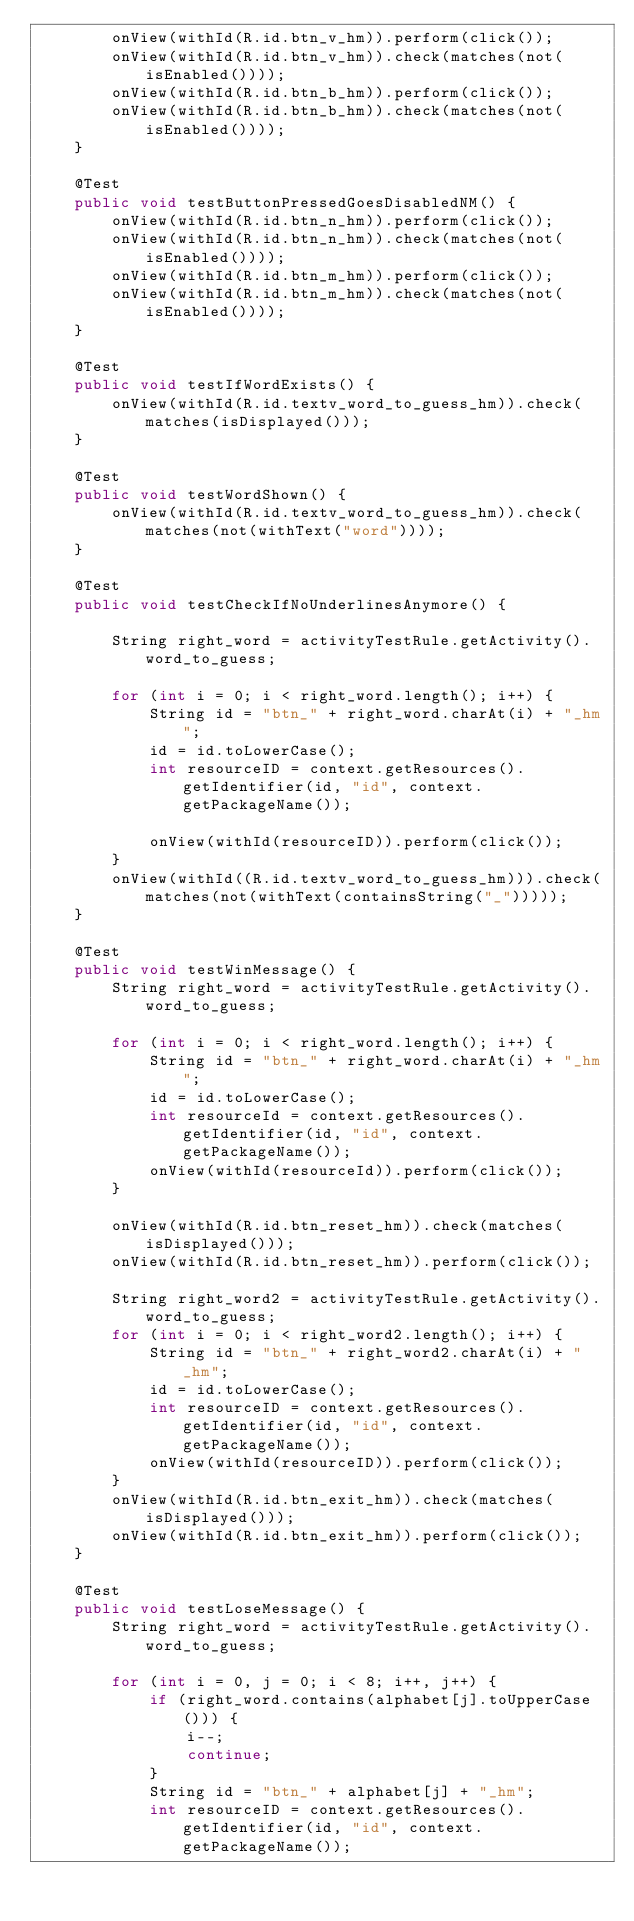<code> <loc_0><loc_0><loc_500><loc_500><_Java_>        onView(withId(R.id.btn_v_hm)).perform(click());
        onView(withId(R.id.btn_v_hm)).check(matches(not(isEnabled())));
        onView(withId(R.id.btn_b_hm)).perform(click());
        onView(withId(R.id.btn_b_hm)).check(matches(not(isEnabled())));
    }

    @Test
    public void testButtonPressedGoesDisabledNM() {
        onView(withId(R.id.btn_n_hm)).perform(click());
        onView(withId(R.id.btn_n_hm)).check(matches(not(isEnabled())));
        onView(withId(R.id.btn_m_hm)).perform(click());
        onView(withId(R.id.btn_m_hm)).check(matches(not(isEnabled())));
    }

    @Test
    public void testIfWordExists() {
        onView(withId(R.id.textv_word_to_guess_hm)).check(matches(isDisplayed()));
    }

    @Test
    public void testWordShown() {
        onView(withId(R.id.textv_word_to_guess_hm)).check(matches(not(withText("word"))));
    }

    @Test
    public void testCheckIfNoUnderlinesAnymore() {

        String right_word = activityTestRule.getActivity().word_to_guess;

        for (int i = 0; i < right_word.length(); i++) {
            String id = "btn_" + right_word.charAt(i) + "_hm";
            id = id.toLowerCase();
            int resourceID = context.getResources().getIdentifier(id, "id", context.getPackageName());

            onView(withId(resourceID)).perform(click());
        }
        onView(withId((R.id.textv_word_to_guess_hm))).check(matches(not(withText(containsString("_")))));
    }

    @Test
    public void testWinMessage() {
        String right_word = activityTestRule.getActivity().word_to_guess;

        for (int i = 0; i < right_word.length(); i++) {
            String id = "btn_" + right_word.charAt(i) + "_hm";
            id = id.toLowerCase();
            int resourceId = context.getResources().getIdentifier(id, "id", context.getPackageName());
            onView(withId(resourceId)).perform(click());
        }

        onView(withId(R.id.btn_reset_hm)).check(matches(isDisplayed()));
        onView(withId(R.id.btn_reset_hm)).perform(click());

        String right_word2 = activityTestRule.getActivity().word_to_guess;
        for (int i = 0; i < right_word2.length(); i++) {
            String id = "btn_" + right_word2.charAt(i) + "_hm";
            id = id.toLowerCase();
            int resourceID = context.getResources().getIdentifier(id, "id", context.getPackageName());
            onView(withId(resourceID)).perform(click());
        }
        onView(withId(R.id.btn_exit_hm)).check(matches(isDisplayed()));
        onView(withId(R.id.btn_exit_hm)).perform(click());
    }

    @Test
    public void testLoseMessage() {
        String right_word = activityTestRule.getActivity().word_to_guess;

        for (int i = 0, j = 0; i < 8; i++, j++) {
            if (right_word.contains(alphabet[j].toUpperCase())) {
                i--;
                continue;
            }
            String id = "btn_" + alphabet[j] + "_hm";
            int resourceID = context.getResources().getIdentifier(id, "id", context.getPackageName());</code> 